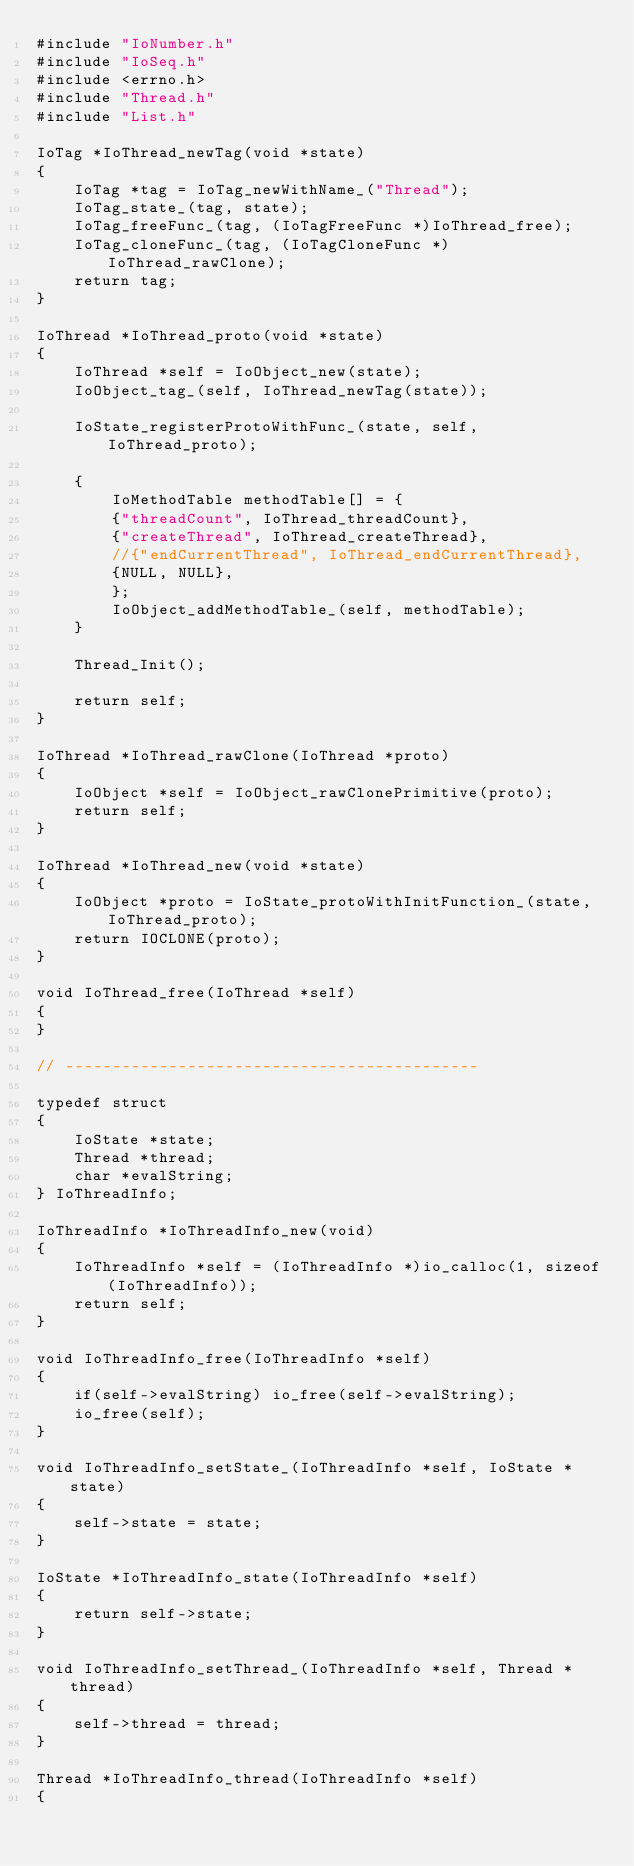<code> <loc_0><loc_0><loc_500><loc_500><_C_>#include "IoNumber.h"
#include "IoSeq.h"
#include <errno.h>
#include "Thread.h"
#include "List.h"

IoTag *IoThread_newTag(void *state)
{
	IoTag *tag = IoTag_newWithName_("Thread");
	IoTag_state_(tag, state);
	IoTag_freeFunc_(tag, (IoTagFreeFunc *)IoThread_free);
	IoTag_cloneFunc_(tag, (IoTagCloneFunc *)IoThread_rawClone);
	return tag;
}

IoThread *IoThread_proto(void *state)
{
	IoThread *self = IoObject_new(state);
	IoObject_tag_(self, IoThread_newTag(state));

	IoState_registerProtoWithFunc_(state, self, IoThread_proto);

	{
		IoMethodTable methodTable[] = {
		{"threadCount", IoThread_threadCount},
		{"createThread", IoThread_createThread},
		//{"endCurrentThread", IoThread_endCurrentThread},
		{NULL, NULL},
		};
		IoObject_addMethodTable_(self, methodTable);
	}

	Thread_Init();

	return self;
}

IoThread *IoThread_rawClone(IoThread *proto)
{
	IoObject *self = IoObject_rawClonePrimitive(proto);
	return self;
}

IoThread *IoThread_new(void *state)
{
	IoObject *proto = IoState_protoWithInitFunction_(state, IoThread_proto);
	return IOCLONE(proto);
}

void IoThread_free(IoThread *self)
{
}

// --------------------------------------------

typedef struct
{
	IoState *state;
	Thread *thread;
	char *evalString;
} IoThreadInfo;

IoThreadInfo *IoThreadInfo_new(void)
{
	IoThreadInfo *self = (IoThreadInfo *)io_calloc(1, sizeof(IoThreadInfo));
	return self;
}

void IoThreadInfo_free(IoThreadInfo *self)
{
	if(self->evalString) io_free(self->evalString);
	io_free(self);
}

void IoThreadInfo_setState_(IoThreadInfo *self, IoState *state)
{
	self->state = state;
}

IoState *IoThreadInfo_state(IoThreadInfo *self)
{
	return self->state;
}

void IoThreadInfo_setThread_(IoThreadInfo *self, Thread *thread)
{
	self->thread = thread;
}

Thread *IoThreadInfo_thread(IoThreadInfo *self)
{</code> 